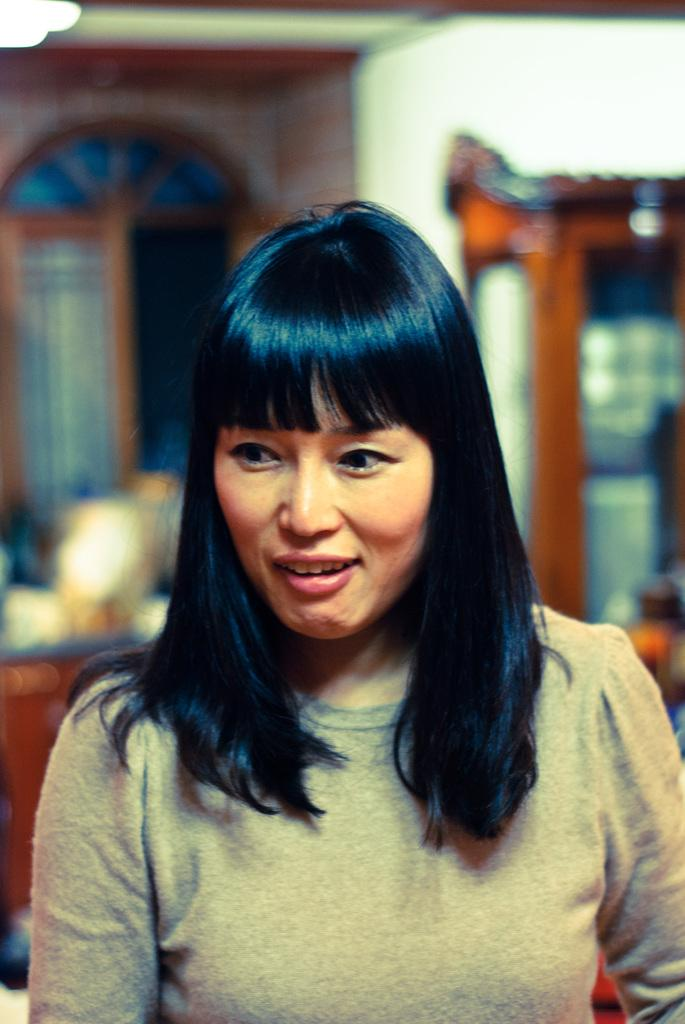What is the main subject of the image? There is a woman in the image. Can you describe the background of the image? The background of the image contains wooden objects. How many snakes are present on the stage in the image? There is no stage or snake present in the image. Are the woman's brothers visible in the image? The facts provided do not mention any brothers, so we cannot determine if they are present in the image. 